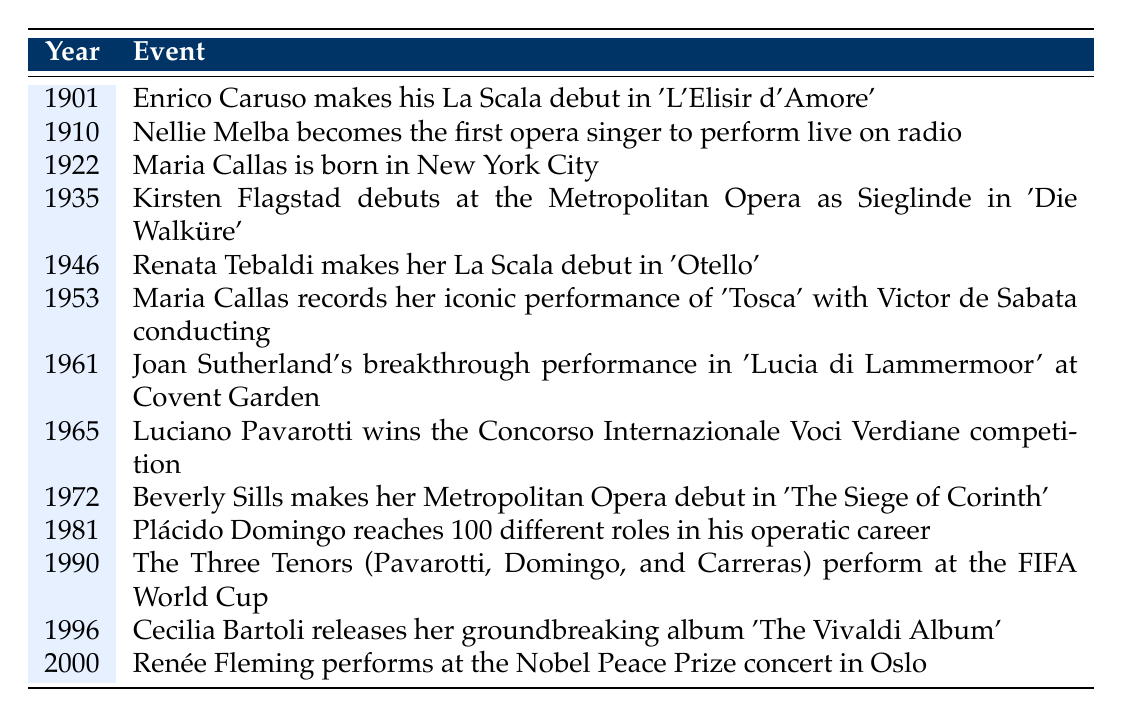What year did Enrico Caruso make his La Scala debut? The table states that Enrico Caruso made his La Scala debut in the year 1901.
Answer: 1901 Who was born in 1922? The table lists that Maria Callas was born in the year 1922 in New York City.
Answer: Maria Callas How many years apart were Nellie Melba's radio performance and Kirsten Flagstad's Metropolitan Opera debut? Nellie Melba performed live on radio in 1910, while Kirsten Flagstad debuted at the Metropolitan Opera in 1935. The difference is 1935 - 1910 = 25 years.
Answer: 25 years Did Renata Tebaldi perform at La Scala before Maria Callas recorded 'Tosca'? Renata Tebaldi made her La Scala debut in 1946, and Maria Callas recorded 'Tosca' in 1953. Since 1946 is before 1953, the answer is yes.
Answer: Yes Which singer made their debut at the Metropolitan Opera in 1972? The table indicates that Beverly Sills made her Metropolitan Opera debut in 1972 with 'The Siege of Corinth'.
Answer: Beverly Sills How many opera singers debuted at La Scala listed in the table before the 1950s? Enrico Caruso (1901), Renata Tebaldi (1946), and there are 2 total singers who made their La Scala debut before the 1950s.
Answer: 2 What significant achievement did Plácido Domingo reach in 1981? The table indicates that Plácido Domingo reached 100 different roles in his operatic career in 1981.
Answer: 100 different roles Which event occurred last according to the timeline? The table shows that Renée Fleming performed at the Nobel Peace Prize concert in Oslo in the year 2000, which is the last event listed.
Answer: 2000 